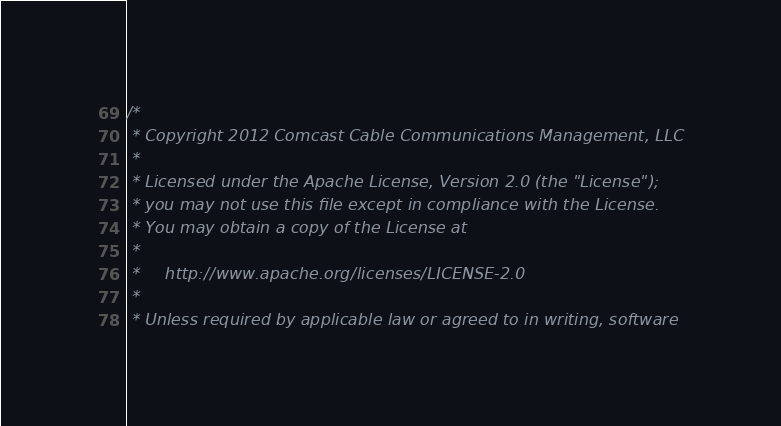Convert code to text. <code><loc_0><loc_0><loc_500><loc_500><_Scala_>/*
 * Copyright 2012 Comcast Cable Communications Management, LLC
 *
 * Licensed under the Apache License, Version 2.0 (the "License");
 * you may not use this file except in compliance with the License.
 * You may obtain a copy of the License at
 *
 *     http://www.apache.org/licenses/LICENSE-2.0
 *
 * Unless required by applicable law or agreed to in writing, software</code> 